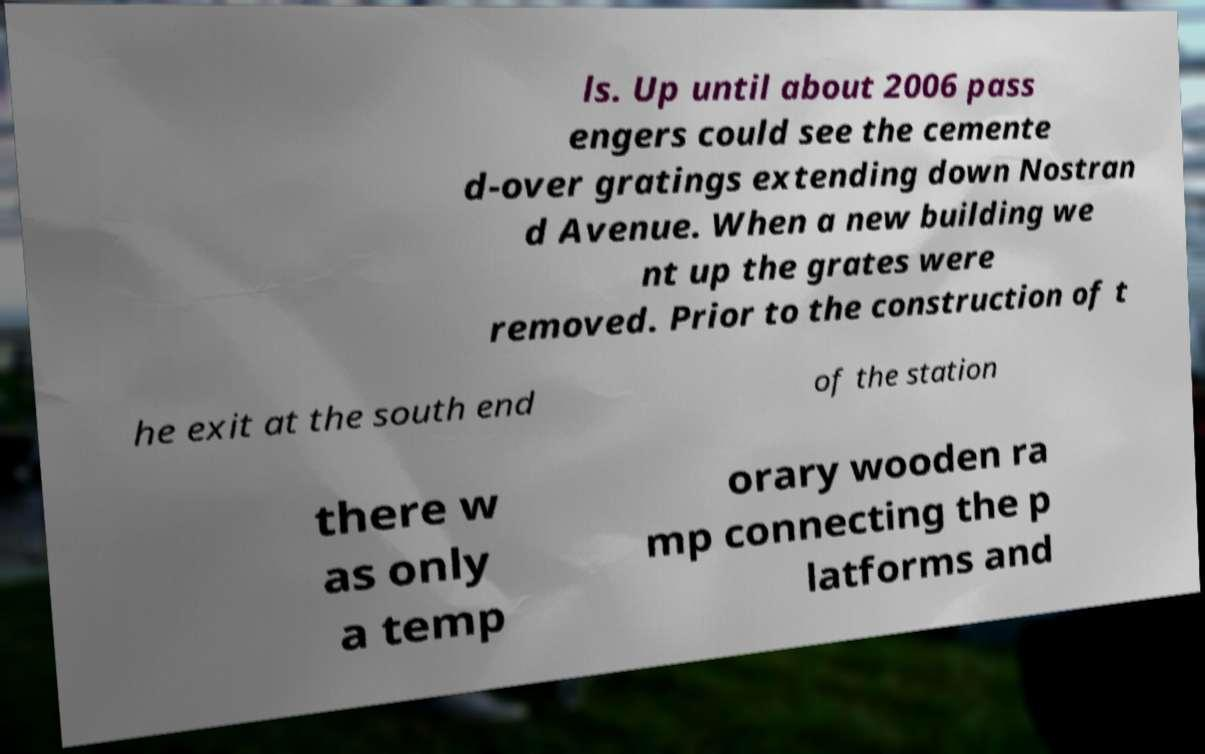Could you assist in decoding the text presented in this image and type it out clearly? ls. Up until about 2006 pass engers could see the cemente d-over gratings extending down Nostran d Avenue. When a new building we nt up the grates were removed. Prior to the construction of t he exit at the south end of the station there w as only a temp orary wooden ra mp connecting the p latforms and 